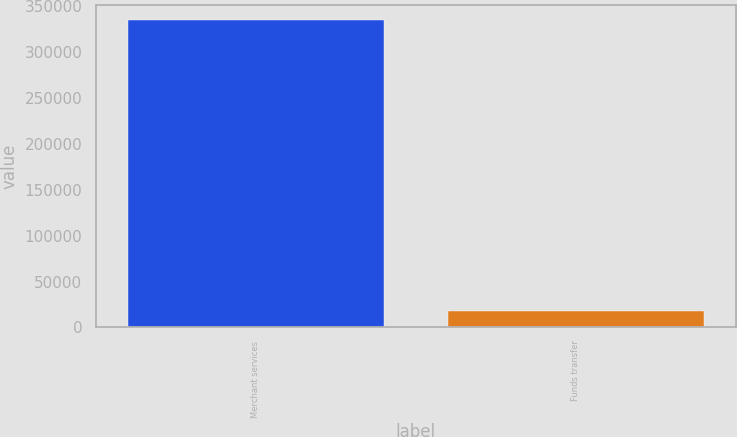Convert chart. <chart><loc_0><loc_0><loc_500><loc_500><bar_chart><fcel>Merchant services<fcel>Funds transfer<nl><fcel>334979<fcel>18216<nl></chart> 